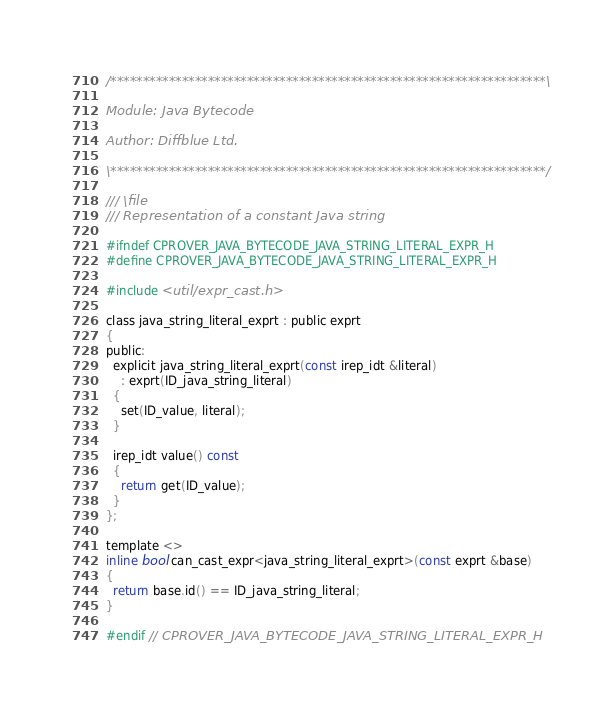Convert code to text. <code><loc_0><loc_0><loc_500><loc_500><_C_>/*******************************************************************\

Module: Java Bytecode

Author: Diffblue Ltd.

\*******************************************************************/

/// \file
/// Representation of a constant Java string

#ifndef CPROVER_JAVA_BYTECODE_JAVA_STRING_LITERAL_EXPR_H
#define CPROVER_JAVA_BYTECODE_JAVA_STRING_LITERAL_EXPR_H

#include <util/expr_cast.h>

class java_string_literal_exprt : public exprt
{
public:
  explicit java_string_literal_exprt(const irep_idt &literal)
    : exprt(ID_java_string_literal)
  {
    set(ID_value, literal);
  }

  irep_idt value() const
  {
    return get(ID_value);
  }
};

template <>
inline bool can_cast_expr<java_string_literal_exprt>(const exprt &base)
{
  return base.id() == ID_java_string_literal;
}

#endif // CPROVER_JAVA_BYTECODE_JAVA_STRING_LITERAL_EXPR_H
</code> 